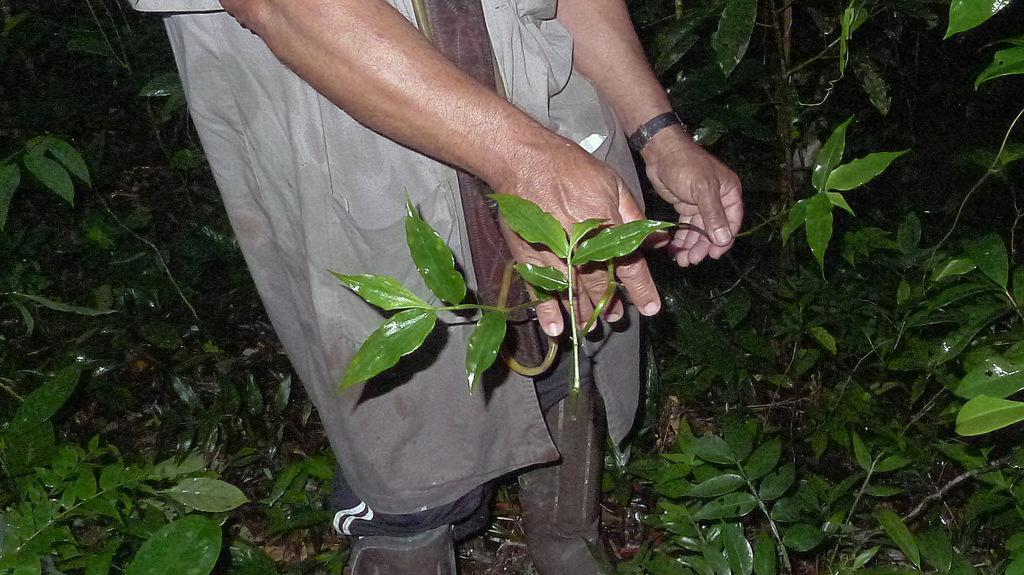Describe this image in one or two sentences. This is the picture of a place where we have a person holding the stem and around there are some plants. 